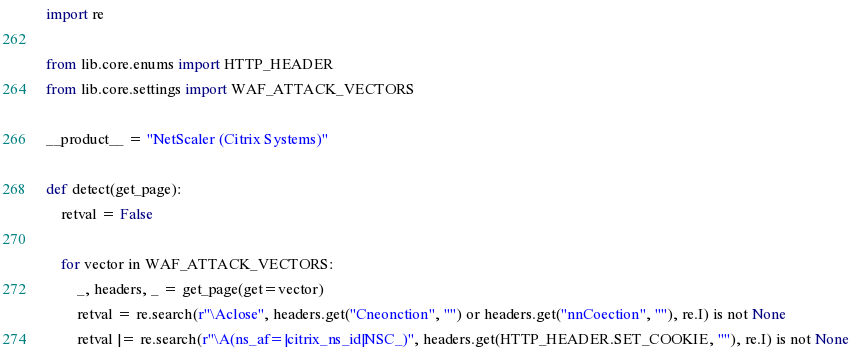Convert code to text. <code><loc_0><loc_0><loc_500><loc_500><_Python_>import re

from lib.core.enums import HTTP_HEADER
from lib.core.settings import WAF_ATTACK_VECTORS

__product__ = "NetScaler (Citrix Systems)"

def detect(get_page):
    retval = False

    for vector in WAF_ATTACK_VECTORS:
        _, headers, _ = get_page(get=vector)
        retval = re.search(r"\Aclose", headers.get("Cneonction", "") or headers.get("nnCoection", ""), re.I) is not None
        retval |= re.search(r"\A(ns_af=|citrix_ns_id|NSC_)", headers.get(HTTP_HEADER.SET_COOKIE, ""), re.I) is not None</code> 